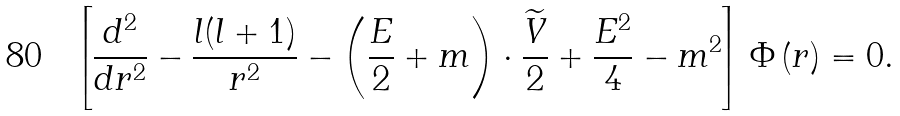Convert formula to latex. <formula><loc_0><loc_0><loc_500><loc_500>\left [ \frac { d ^ { 2 } } { d r ^ { 2 } } - \frac { l ( l + 1 ) } { r ^ { 2 } } - \left ( \frac { E } { 2 } + m \right ) \cdot \frac { \widetilde { V } } 2 + \frac { E ^ { 2 } } 4 - m ^ { 2 } \right ] \Phi \left ( r \right ) = 0 .</formula> 